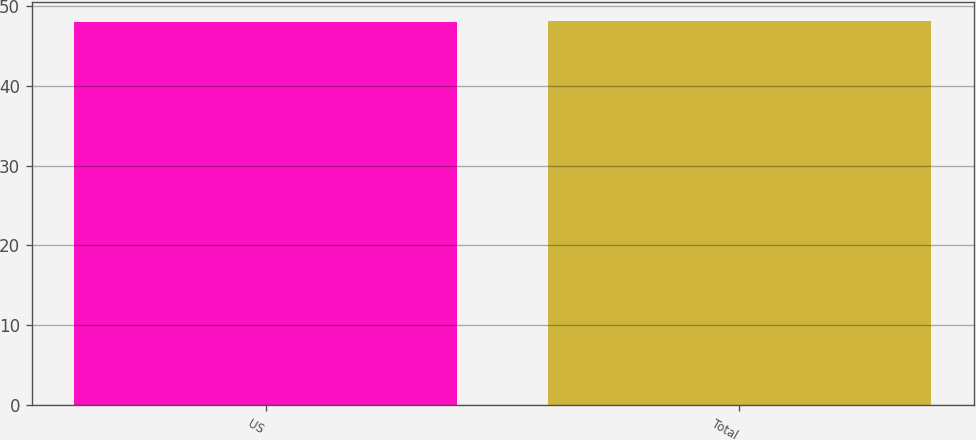Convert chart. <chart><loc_0><loc_0><loc_500><loc_500><bar_chart><fcel>US<fcel>Total<nl><fcel>48<fcel>48.1<nl></chart> 